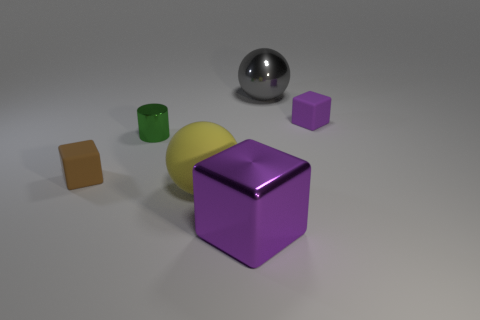Is the shape of the gray object the same as the large rubber object?
Your answer should be compact. Yes. There is a brown thing that is the same material as the yellow object; what size is it?
Offer a very short reply. Small. There is a big ball that is behind the cylinder; how many gray metal things are in front of it?
Provide a succinct answer. 0. Are the purple block that is behind the small brown thing and the cylinder made of the same material?
Provide a succinct answer. No. Is there any other thing that is made of the same material as the cylinder?
Keep it short and to the point. Yes. There is a rubber cube that is right of the tiny matte block that is on the left side of the large rubber object; how big is it?
Your answer should be very brief. Small. There is a purple thing in front of the purple cube that is behind the large metal object that is in front of the brown object; what is its size?
Keep it short and to the point. Large. There is a matte object that is behind the tiny metallic cylinder; does it have the same shape as the green thing that is to the left of the large purple block?
Provide a short and direct response. No. What number of other things are there of the same color as the big metal cube?
Offer a very short reply. 1. Do the matte cube that is on the right side of the purple shiny object and the tiny green object have the same size?
Offer a terse response. Yes. 